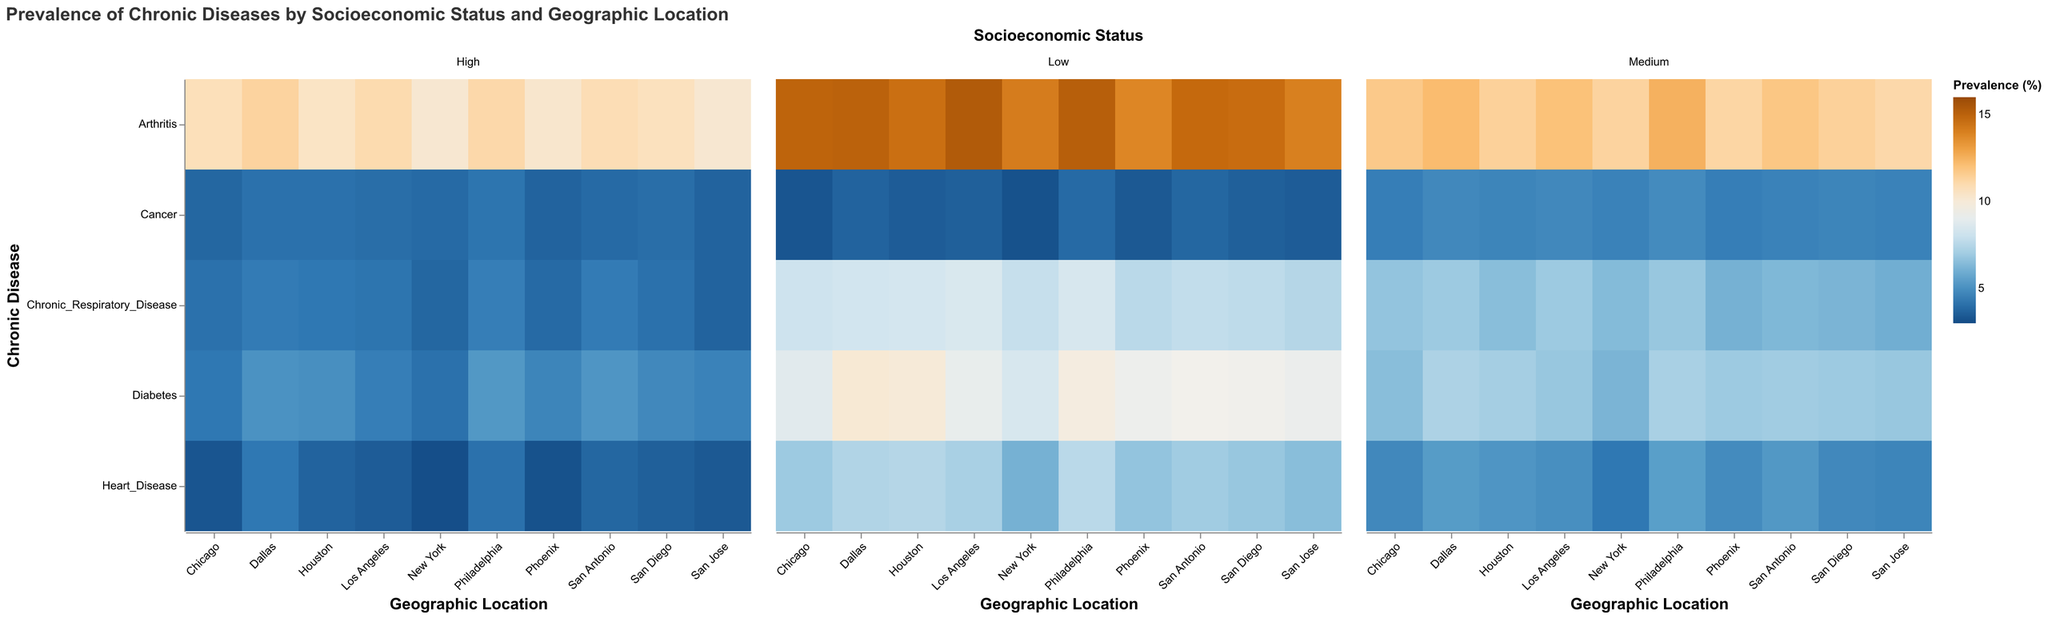What is the title of the figure? The title of the figure can be found at the top, indicating the main subject of the visualization.
Answer: Prevalence of Chronic Diseases by Socioeconomic Status and Geographic Location Which geographic location has the highest prevalence of diabetes in the Medium socioeconomic status group? Locate the Medium socioeconomic status group and find the intersection with the highest color intensity for diabetes.
Answer: Philadelphia Which chronic disease has the lowest prevalence across all geographic locations and socioeconomic statuses? From the color scale, look for the disease with consistently low intensity colors across all facets.
Answer: Cancer In New York, compare the prevalence of heart disease between the Low and High socioeconomic statuses. Which one is higher, and by how much? Look at the New York section and compare the color intensity for heart disease in Low and High socioeconomic statuses, then note the difference in prevalence percentages.
Answer: The Low socioeconomic status has a prevalence of 6.1%, and the High socioeconomic status has 3.1%, so the Low status is higher by 3% What is the average prevalence of arthritis in Los Angeles across all socioeconomic statuses? Sum the prevalence values for arthritis in Los Angeles for Low, Medium, and High socioeconomic statuses, then divide by 3.
Answer: (15.3 + 12.0 + 11.0) / 3 = 12.77% Which geographic location has the lowest prevalence of chronic respiratory disease among the High socioeconomic status? Focus on the High socioeconomic status and find the intersection with the lowest color intensity for chronic respiratory disease.
Answer: San Jose Between Chicago and Phoenix, which city has a higher average prevalence of heart disease across all socioeconomic statuses? Calculate the average prevalence of heart disease for both cities by summing their values and dividing by 3, then compare the results.
Answer: Chicago (5.0%) has a higher average than Phoenix (4.93%) Is there any disease in any city and socioeconomic status that reaches the maximum prevalence (16%) according to the color scale? Check the color intensity for any cells that match the highest color on the prevalence scale.
Answer: No Compare the prevalence of diabetes in the Medium socioeconomic status between Houston and San Antonio. Which one is higher, and by what percentage point? Look at the color intensity for diabetes in the Medium socioeconomic status for both Houston and San Antonio, and calculate the difference.
Answer: Houston (7.1%) is higher than San Antonio (7.0%) by 0.1% How does the prevalence of arthritis in Philadelphia's Low socioeconomic status compare to that in Dallas's Low socioeconomic status? Compare the color intensity and prevalence percentage values for arthritis in the Low socioeconomic status of both cities.
Answer: Philadelphia (15.1%) is slightly lower than Dallas (15.0%) by 0.1% 